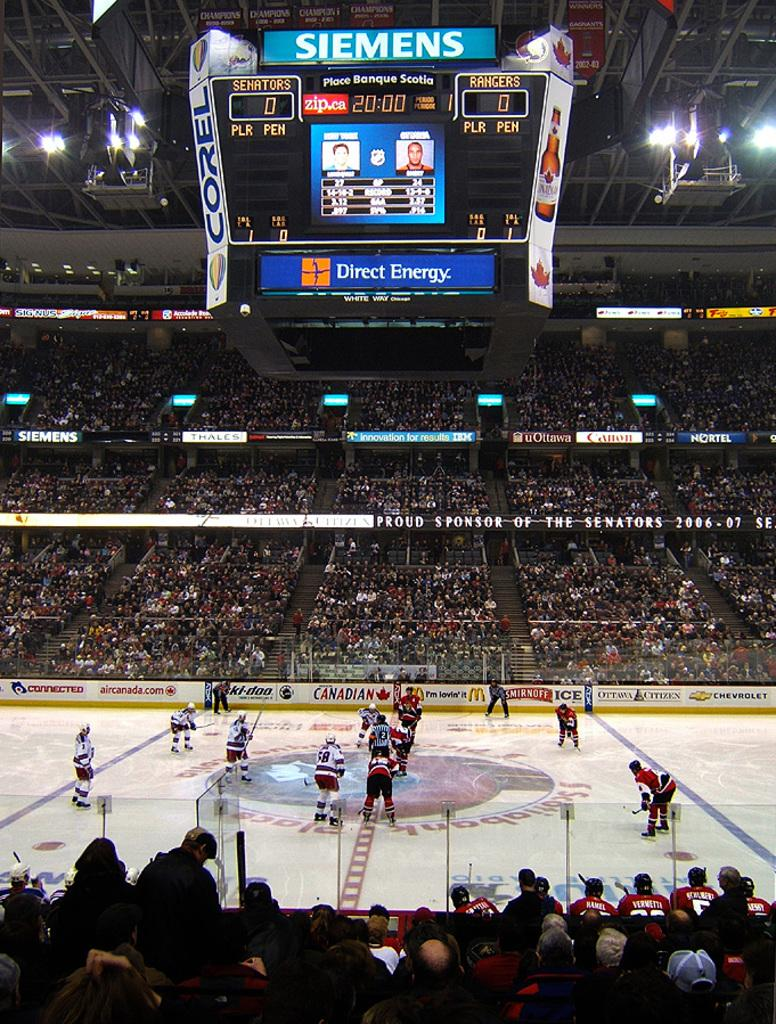Provide a one-sentence caption for the provided image. A hockey game being played with scoreboard ad for Direct energy and Siemens. 